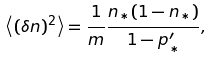Convert formula to latex. <formula><loc_0><loc_0><loc_500><loc_500>\left < ( \delta n ) ^ { 2 } \right > = \frac { 1 } { m } \frac { n _ { * } ( 1 - n _ { * } ) } { 1 - p _ { * } ^ { \prime } } ,</formula> 